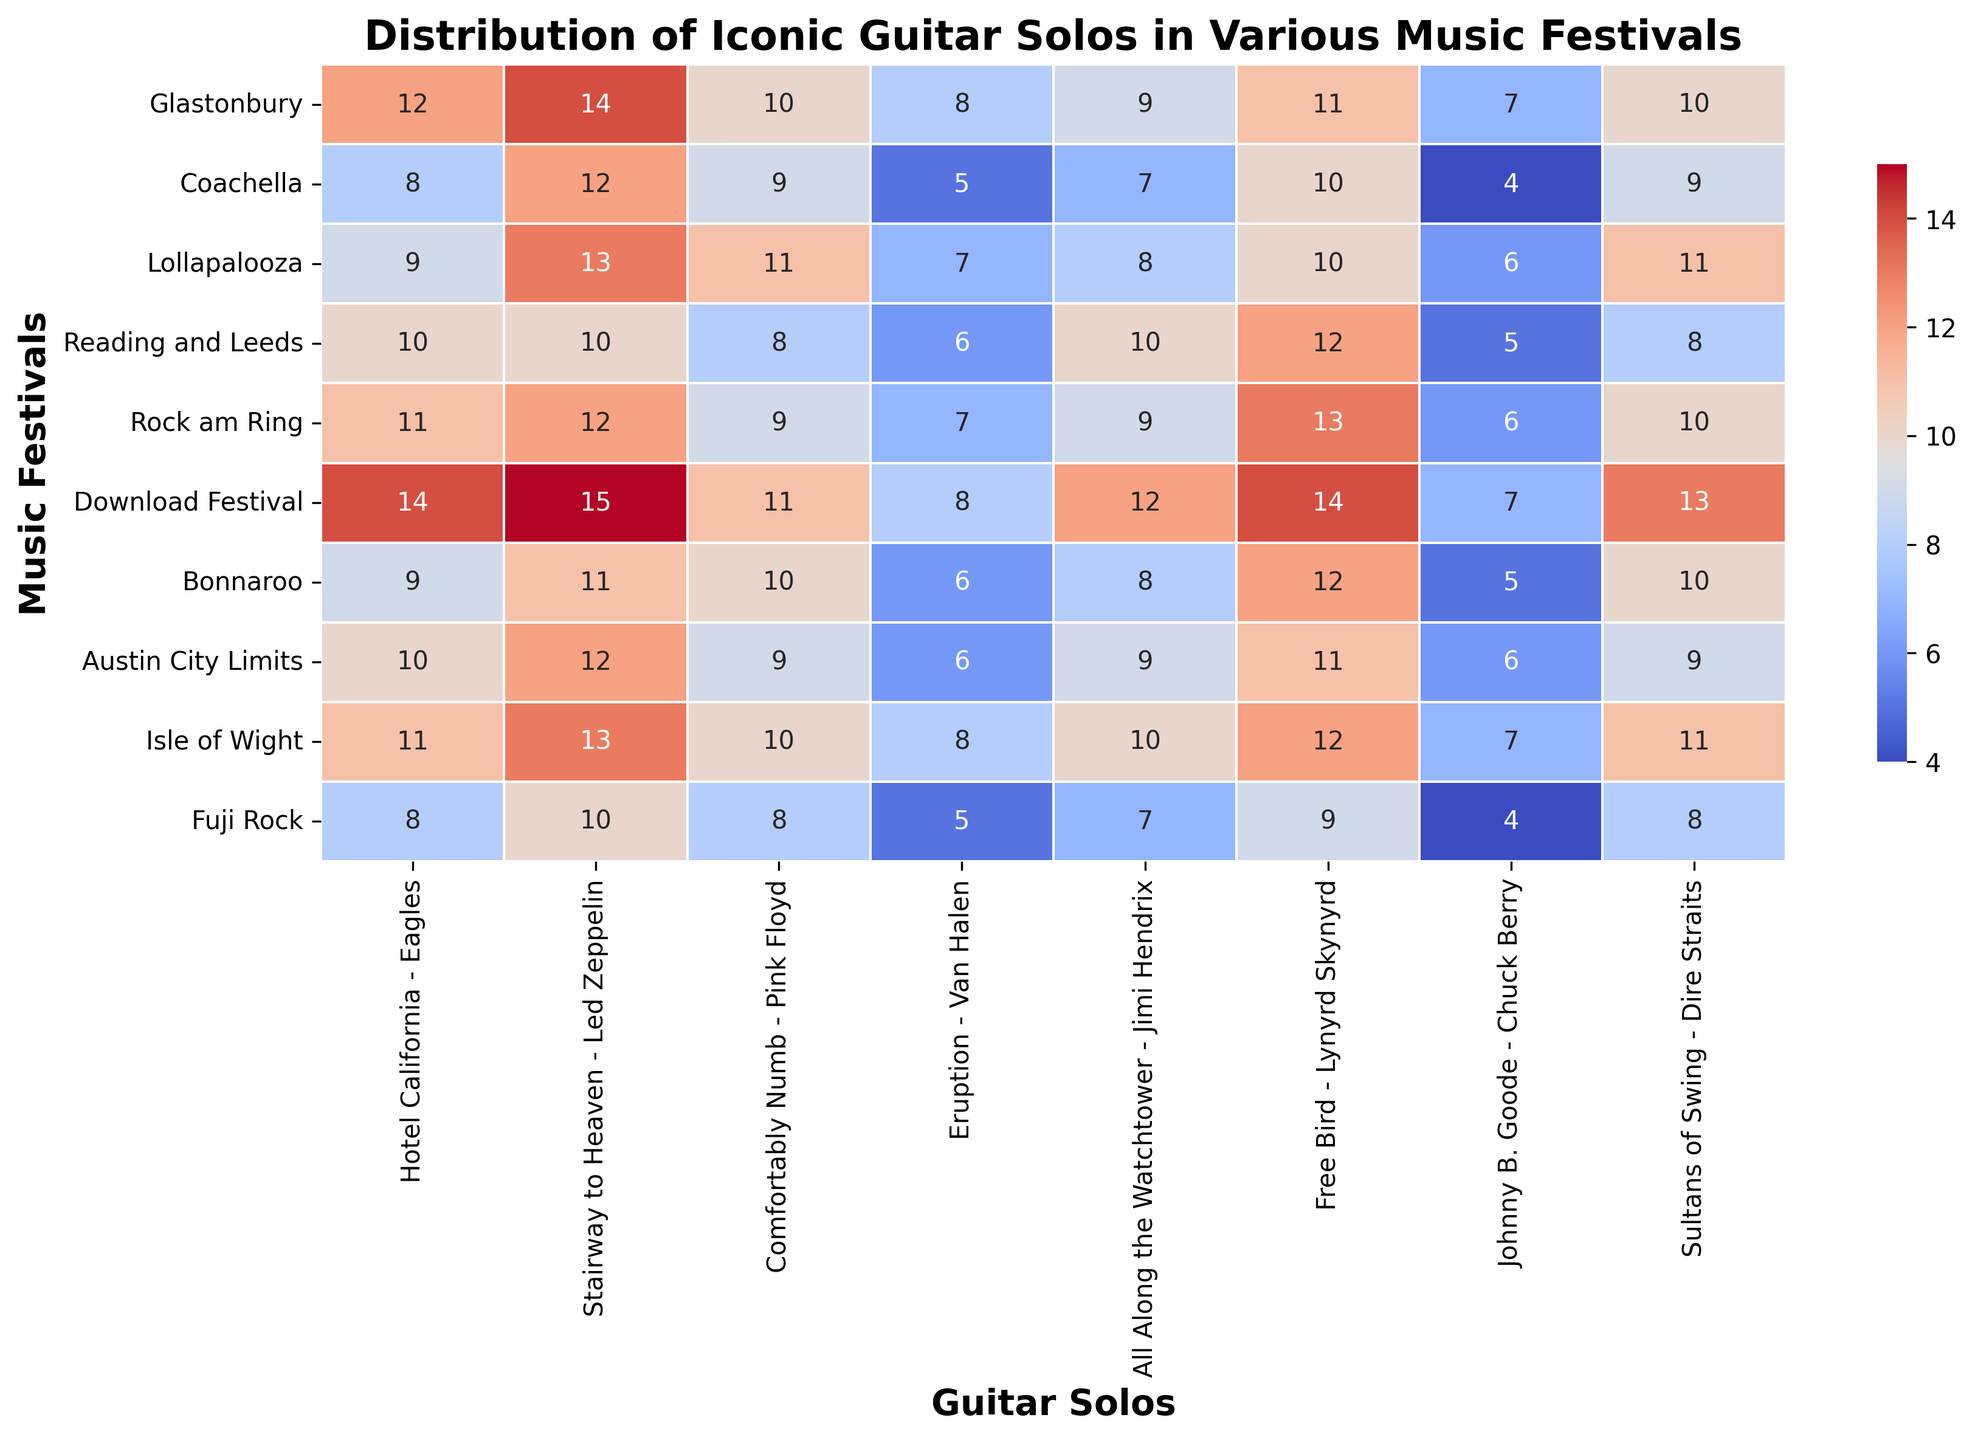What's the most frequently played solo at the Download Festival? Looking at the Download Festival row, the highest frequency number is 15 for "Stairway to Heaven - Led Zeppelin"
Answer: Stairway to Heaven - Led Zeppelin Which festival featured "Eruption - Van Halen" the least? By scanning the "Eruption - Van Halen" column, the lowest number appears in Fuji Rock with a frequency of 5
Answer: Fuji Rock How many times was "Johnny B. Goode - Chuck Berry" played across all festivals? Adding "Johnny B. Goode - Chuck Berry" frequencies across all festivals: 7 + 4 + 6 + 5 + 6 + 7 + 5 + 6 + 7 + 4 = 57
Answer: 57 Which solo has the closest frequency of being played in Coachella and Austin City Limits? Comparing the values for Coachella and Austin City Limits, "Comfortably Numb - Pink Floyd" both have a frequency of 9
Answer: Comfortably Numb - Pink Floyd What's the average frequency of "Hotel California - Eagles" across all festivals? Adding frequencies for "Hotel California - Eagles" then dividing by 10: (12 + 8 + 9 + 10 + 11 + 14 + 9 + 10 + 11 + 8) / 10 = 10.2
Answer: 10.2 Which festival played "Free Bird - Lynyrd Skynyrd" the most often? In the "Free Bird - Lynyrd Skynyrd" column, the highest frequency of 14 appears for the Download Festival
Answer: Download Festival Compare the total occurrences of "All Along the Watchtower - Jimi Hendrix" with "Sultans of Swing - Dire Straits" across all festivals. Which is more frequent? Sum the frequencies: "All Along the Watchtower - Jimi Hendrix" is 9 + 7 + 8 + 10 + 9 + 12 + 8 + 9 + 10 + 7 = 89, "Sultans of Swing - Dire Straits" is 10 + 9 + 11 + 8 + 10 + 13 + 10 + 9 + 11 + 8 = 89. Both totals are the same
Answer: Both are the same What's the median frequency of "Hotel California - Eagles" across the festivals? Sorting the values: 8, 8, 9, 9, 10, 10, 11, 11, 12, 14. The middle values being 10 and 10, the median is 10
Answer: 10 Which solo has the greatest variance in frequency across all festivals? Calculating the variance:
- Hotel California: Var = ((2 - 10.2)^2 + (8 - 10.2)^2 + ... + (8 - 10.2)^2) / 10 = 3.84
- Stairway to Heaven: Var = ((14 - 12.6)^2 + (12 - 12.6)^2 + ... + (10 - 12.6)^2) / 10 = 3.84
- Comfortably Numb: Var = 2.84
- Eruption: Var = 1.84
- All Along the Watchtower: Var = 3.44
- Free Bird: Var = 2.84
- Johnny B. Goode: Var = 2.84
- Sultans of Swing: Var = 3.84
"Hotel California", "Stairway to Heaven", and "Sultans of Swing" all have the highest variance of 3.84
Answer: Hotel California, Stairway to Heaven, Sultans of Swing 